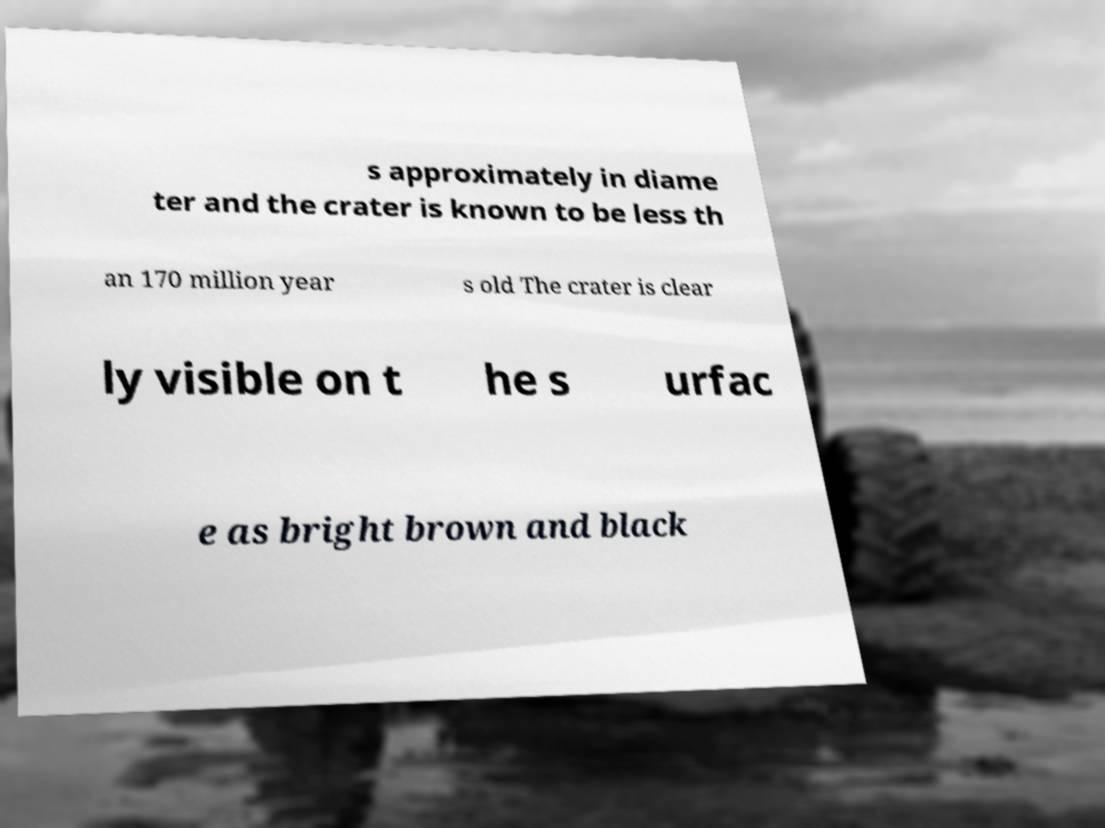I need the written content from this picture converted into text. Can you do that? s approximately in diame ter and the crater is known to be less th an 170 million year s old The crater is clear ly visible on t he s urfac e as bright brown and black 